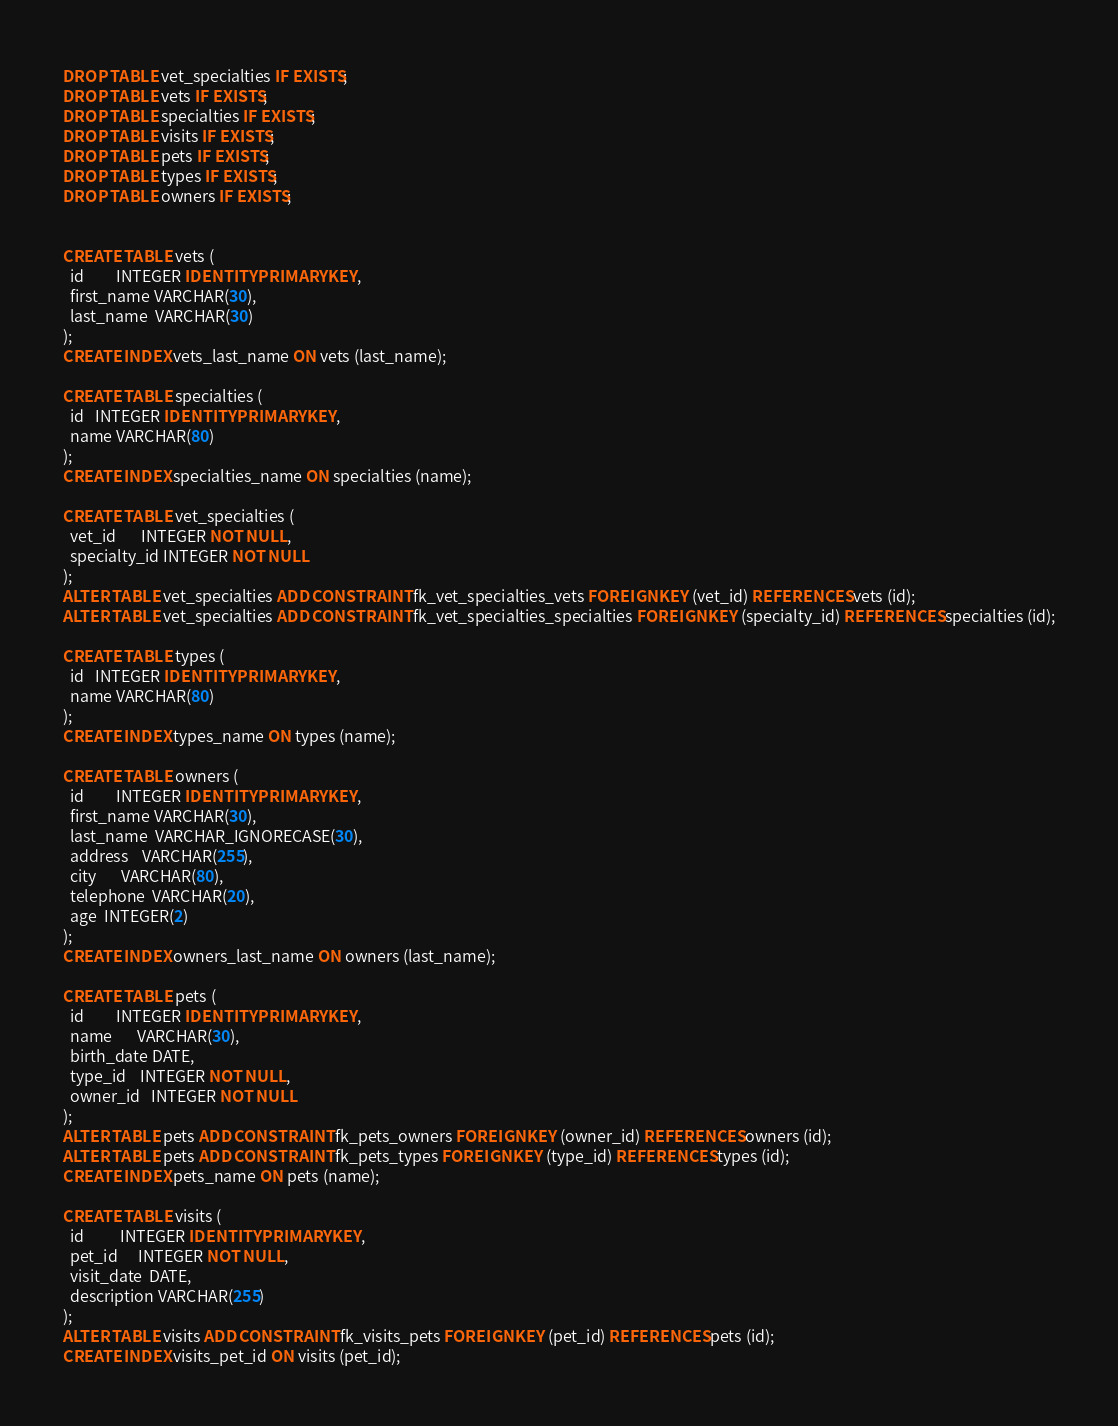Convert code to text. <code><loc_0><loc_0><loc_500><loc_500><_SQL_>DROP TABLE vet_specialties IF EXISTS;
DROP TABLE vets IF EXISTS;
DROP TABLE specialties IF EXISTS;
DROP TABLE visits IF EXISTS;
DROP TABLE pets IF EXISTS;
DROP TABLE types IF EXISTS;
DROP TABLE owners IF EXISTS;


CREATE TABLE vets (
  id         INTEGER IDENTITY PRIMARY KEY,
  first_name VARCHAR(30),
  last_name  VARCHAR(30)
);
CREATE INDEX vets_last_name ON vets (last_name);

CREATE TABLE specialties (
  id   INTEGER IDENTITY PRIMARY KEY,
  name VARCHAR(80)
);
CREATE INDEX specialties_name ON specialties (name);

CREATE TABLE vet_specialties (
  vet_id       INTEGER NOT NULL,
  specialty_id INTEGER NOT NULL
);
ALTER TABLE vet_specialties ADD CONSTRAINT fk_vet_specialties_vets FOREIGN KEY (vet_id) REFERENCES vets (id);
ALTER TABLE vet_specialties ADD CONSTRAINT fk_vet_specialties_specialties FOREIGN KEY (specialty_id) REFERENCES specialties (id);

CREATE TABLE types (
  id   INTEGER IDENTITY PRIMARY KEY,
  name VARCHAR(80)
);
CREATE INDEX types_name ON types (name);

CREATE TABLE owners (
  id         INTEGER IDENTITY PRIMARY KEY,
  first_name VARCHAR(30),
  last_name  VARCHAR_IGNORECASE(30),
  address    VARCHAR(255),
  city       VARCHAR(80),
  telephone  VARCHAR(20),
  age  INTEGER(2)
);
CREATE INDEX owners_last_name ON owners (last_name);

CREATE TABLE pets (
  id         INTEGER IDENTITY PRIMARY KEY,
  name       VARCHAR(30),
  birth_date DATE,
  type_id    INTEGER NOT NULL,
  owner_id   INTEGER NOT NULL
);
ALTER TABLE pets ADD CONSTRAINT fk_pets_owners FOREIGN KEY (owner_id) REFERENCES owners (id);
ALTER TABLE pets ADD CONSTRAINT fk_pets_types FOREIGN KEY (type_id) REFERENCES types (id);
CREATE INDEX pets_name ON pets (name);

CREATE TABLE visits (
  id          INTEGER IDENTITY PRIMARY KEY,
  pet_id      INTEGER NOT NULL,
  visit_date  DATE,
  description VARCHAR(255)
);
ALTER TABLE visits ADD CONSTRAINT fk_visits_pets FOREIGN KEY (pet_id) REFERENCES pets (id);
CREATE INDEX visits_pet_id ON visits (pet_id);
</code> 